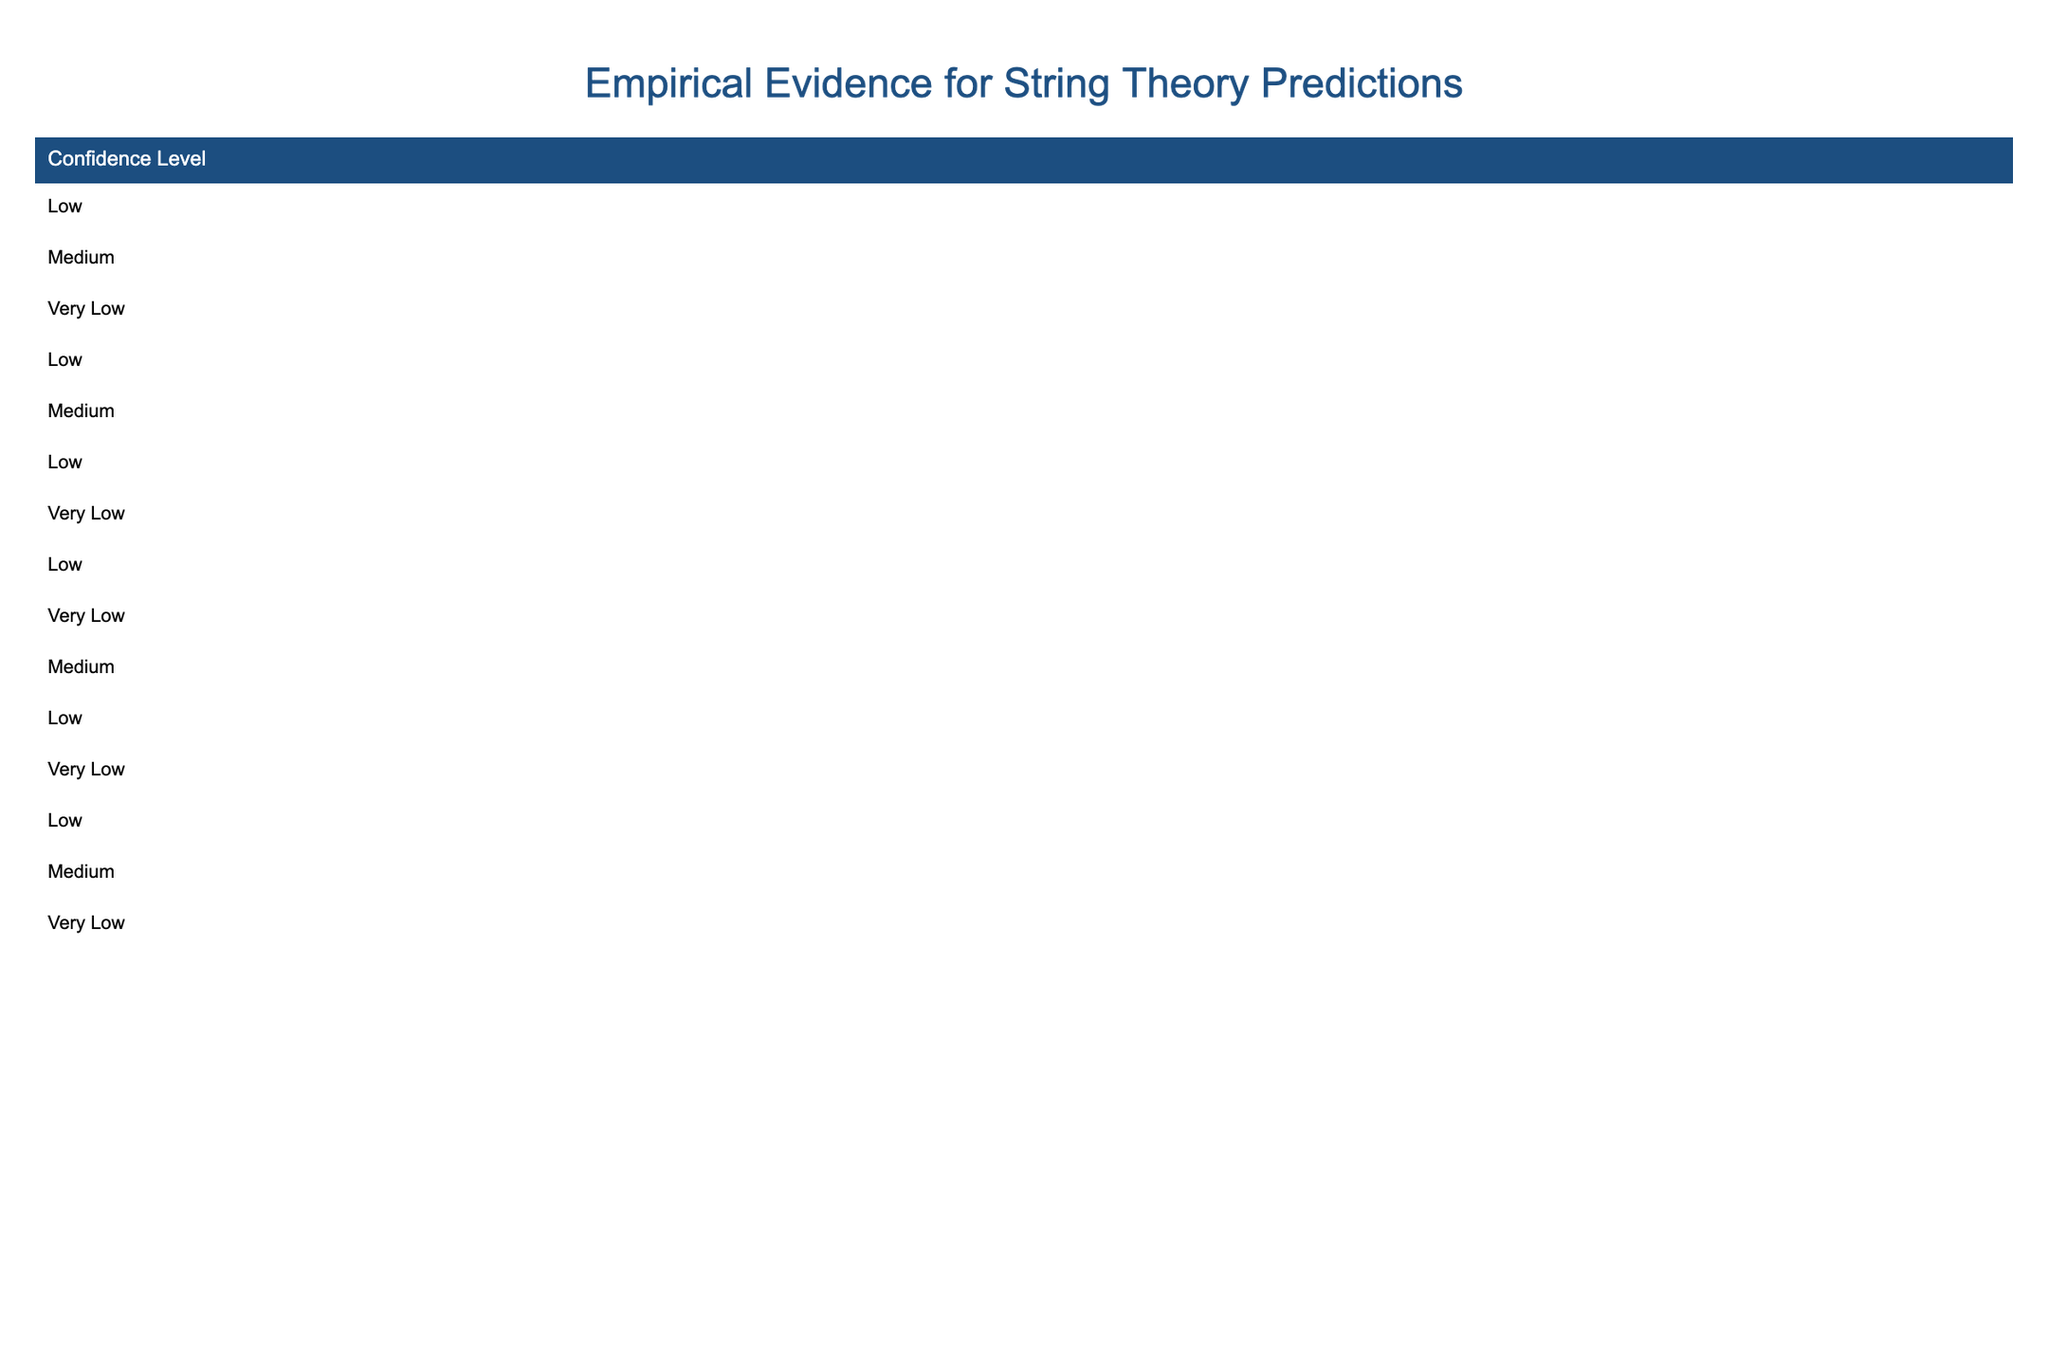What is the prediction associated with Harvard University? According to the table, Harvard University is associated with the prediction of Quantum Entanglement under the Holographic Principle.
Answer: Quantum Entanglement Which institution reported the highest confidence level for empirical evidence? In the table, the highest confidence level reported is 'Medium' by both Caltech and Harvard University; therefore, there is no single institution with the highest level.
Answer: None How many predictions in the table have 'No detection' as evidence? By counting, there are 4 predictions listed in the table that mention 'No detection' as evidence: Cosmic Strings, String Bursts, Proton Decay, and Extra Dimensions.
Answer: 4 Which institution conducted research on Dark Matter Candidates, and what was the confidence level? The institution is Fermilab, and the confidence level for the empirical evidence regarding Dark Matter Candidates is Medium.
Answer: Fermilab, Medium Is there any empirical evidence supporting the predictions related to string theory? The table shows that while there are various predictions, none have strong empirical evidence; most are either inconclusive, low, or very low, thereby affirming the lack of support.
Answer: No What percentages of predictions listed have a confidence level of 'Very Low'? There are 7 predictions listed with a confidence level of 'Very Low' out of 15 total predictions, which translates to (7/15)*100 = 46.67%.
Answer: 46.67% What is the common empirical evidence status among the predictions from Tokyo University and University of Cambridge? Both institutions report 'No experimental validation' or 'Undetected', indicating a similar lack of supportive empirical evidence.
Answer: Similar lack of evidence Which year had the highest number of entries regarding predictions, according to the table? By reviewing the years, 2017 has 3 entries (MIT, University of Oxford, Tokyo University), which is the most notable year listed in the table.
Answer: 2017 What ratio of predictions shows 'Inconclusive results'? There is 1 prediction with 'Inconclusive results' out of 15 predictions total, making the ratio 1:15.
Answer: 1:15 Which research area has the most predictions associated with it, based on the data? The research area of String Phenomenology has 2 predictions associated (Supersymmetry and Proton Decay), which is comparatively high among the areas listed.
Answer: String Phenomenology 